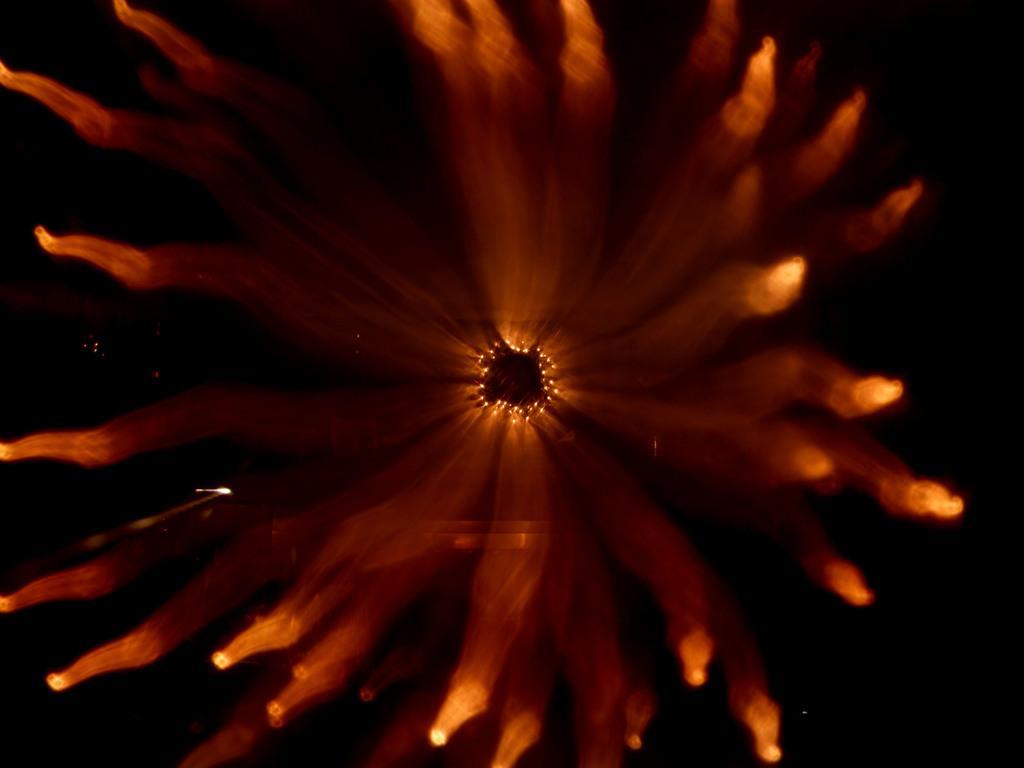In one or two sentences, can you explain what this image depicts? In this image we can see a picture which looks like a flower with dark background. 